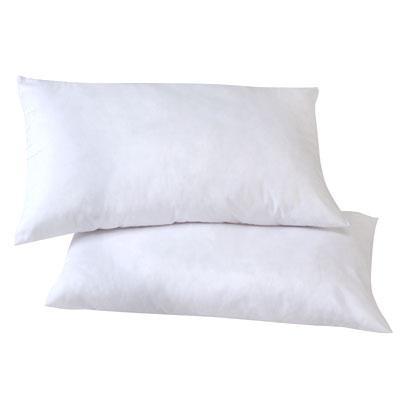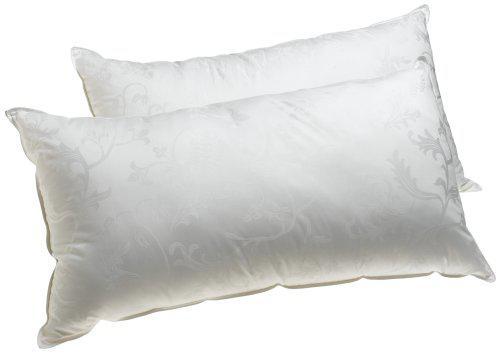The first image is the image on the left, the second image is the image on the right. Examine the images to the left and right. Is the description "One of the images has fewer than two pillows." accurate? Answer yes or no. No. The first image is the image on the left, the second image is the image on the right. Considering the images on both sides, is "Each image contains two pillows, and all pillows are rectangular rather than square." valid? Answer yes or no. Yes. 